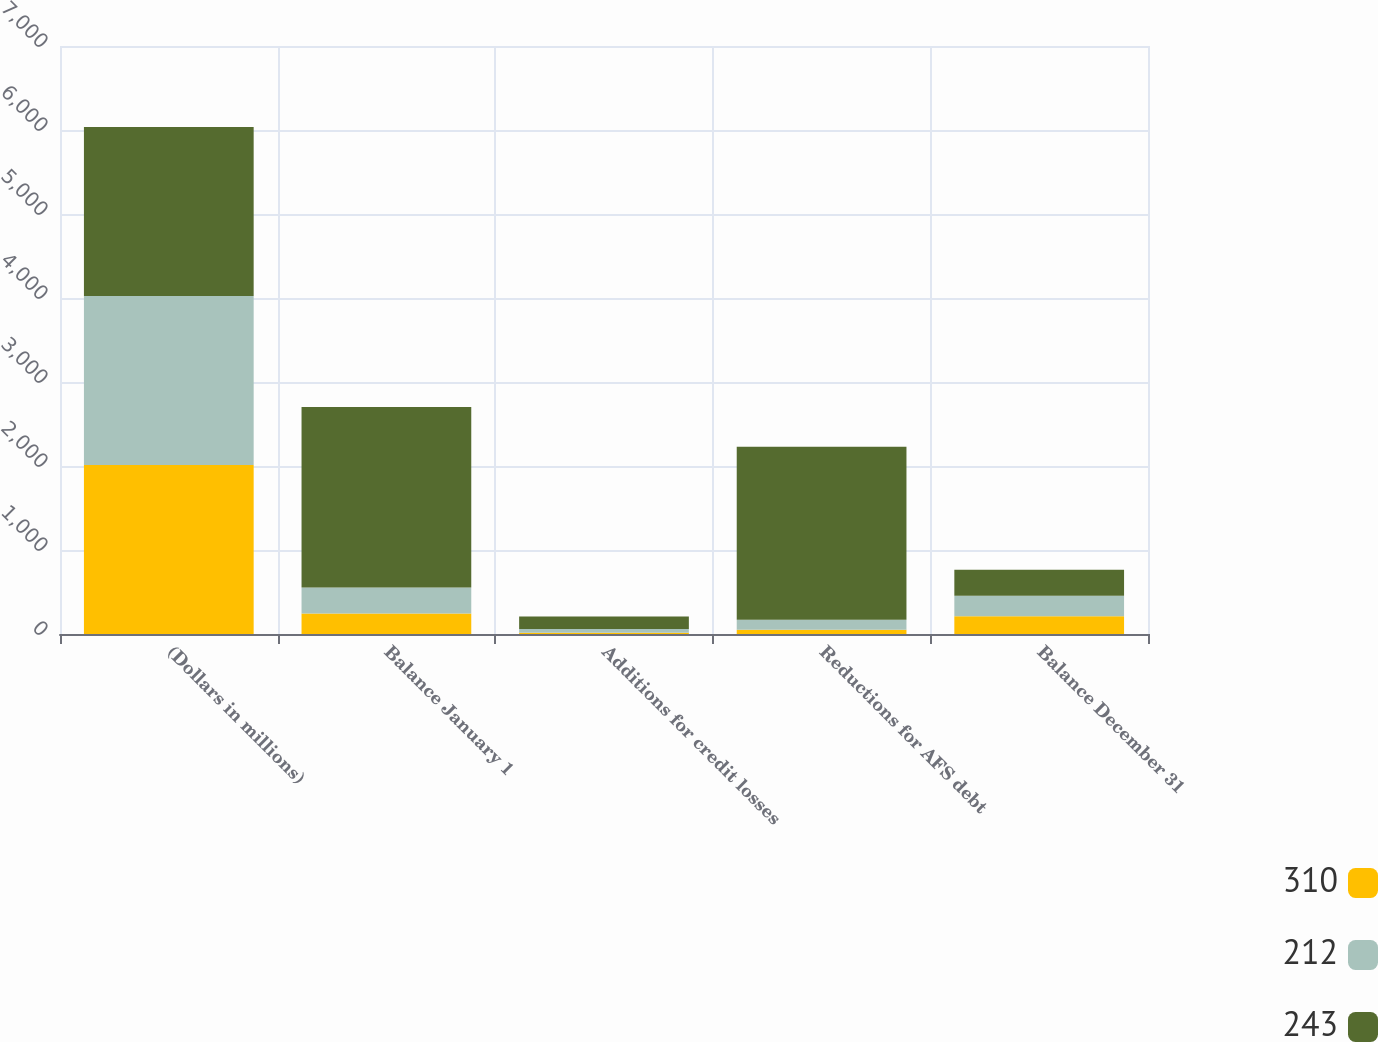Convert chart to OTSL. <chart><loc_0><loc_0><loc_500><loc_500><stacked_bar_chart><ecel><fcel>(Dollars in millions)<fcel>Balance January 1<fcel>Additions for credit losses<fcel>Reductions for AFS debt<fcel>Balance December 31<nl><fcel>310<fcel>2013<fcel>243<fcel>14<fcel>51<fcel>212<nl><fcel>212<fcel>2012<fcel>310<fcel>46<fcel>120<fcel>243<nl><fcel>243<fcel>2011<fcel>2148<fcel>149<fcel>2059<fcel>310<nl></chart> 